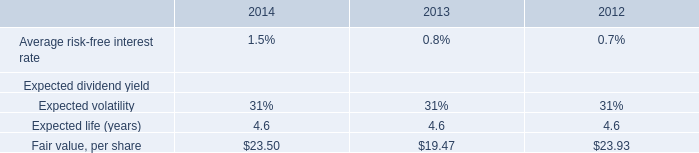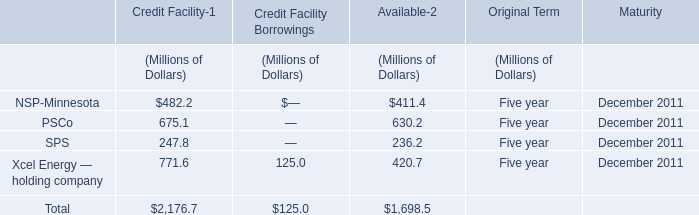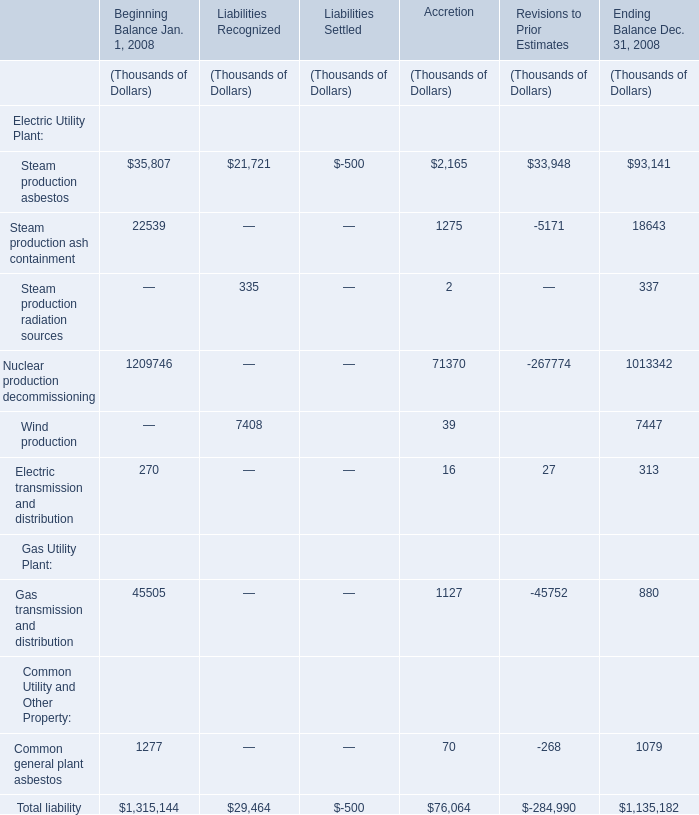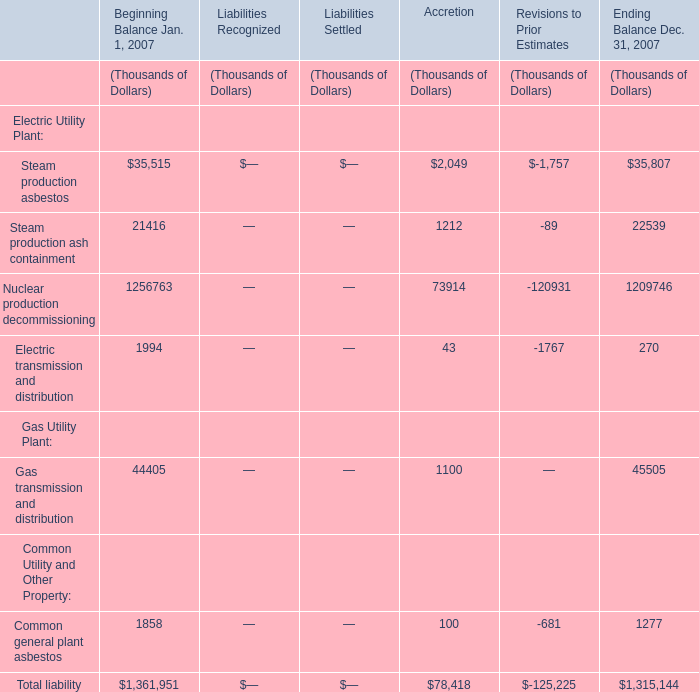Which liability exceeds 30 % of total in Ending Balance Dec. 31, 2007 ? 
Computations: (1315144 * 0.3)
Answer: 394543.2. 